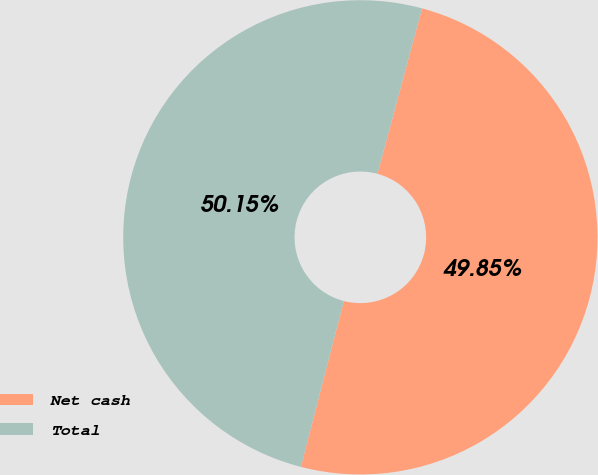Convert chart to OTSL. <chart><loc_0><loc_0><loc_500><loc_500><pie_chart><fcel>Net cash<fcel>Total<nl><fcel>49.85%<fcel>50.15%<nl></chart> 